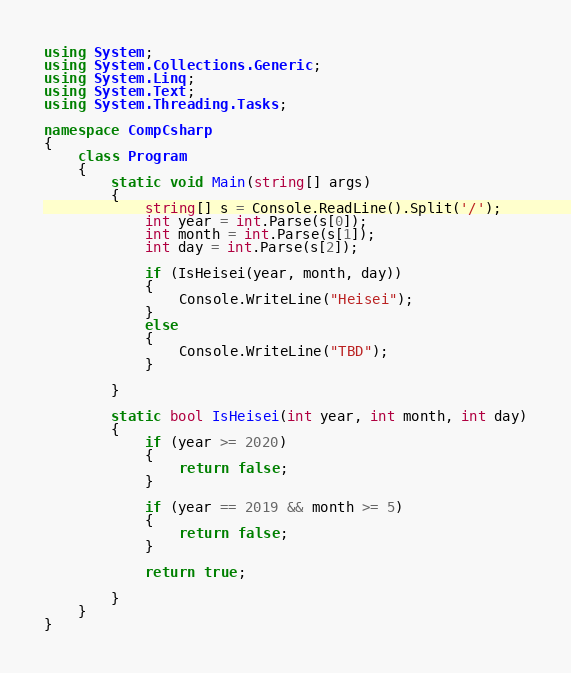Convert code to text. <code><loc_0><loc_0><loc_500><loc_500><_C#_>using System;
using System.Collections.Generic;
using System.Linq;
using System.Text;
using System.Threading.Tasks;

namespace CompCsharp
{
    class Program
    {
        static void Main(string[] args)
        {
            string[] s = Console.ReadLine().Split('/');
            int year = int.Parse(s[0]);
            int month = int.Parse(s[1]);
            int day = int.Parse(s[2]);

            if (IsHeisei(year, month, day))
            {
                Console.WriteLine("Heisei");
            }
            else
            {
                Console.WriteLine("TBD");
            }
                
        }

        static bool IsHeisei(int year, int month, int day)
        {
            if (year >= 2020)
            {
                return false;
            }

            if (year == 2019 && month >= 5)
            {
                return false;
            }

            return true;

        }
    }
}
</code> 